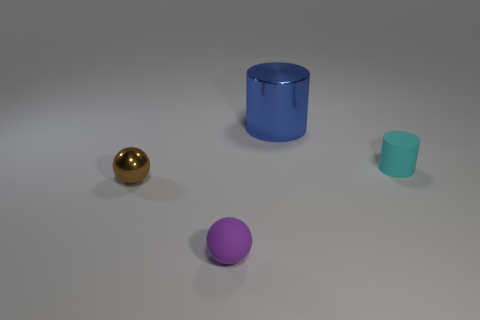How many objects are either red cylinders or small rubber objects?
Offer a terse response. 2. How many other things are the same shape as the purple matte thing?
Your answer should be compact. 1. Do the tiny purple thing that is to the left of the cyan cylinder and the blue cylinder that is behind the brown shiny object have the same material?
Your answer should be very brief. No. What is the shape of the small thing that is both on the right side of the tiny shiny object and behind the tiny purple thing?
Ensure brevity in your answer.  Cylinder. What material is the thing that is both on the right side of the tiny brown thing and on the left side of the big object?
Offer a terse response. Rubber. There is a brown thing that is made of the same material as the blue thing; what is its shape?
Make the answer very short. Sphere. Is the number of things on the left side of the large blue shiny cylinder greater than the number of small green spheres?
Give a very brief answer. Yes. What is the material of the tiny cyan cylinder?
Your answer should be very brief. Rubber. What number of purple cylinders have the same size as the matte sphere?
Make the answer very short. 0. Are there an equal number of big blue shiny cylinders left of the blue cylinder and rubber cylinders that are to the right of the brown metallic ball?
Give a very brief answer. No. 